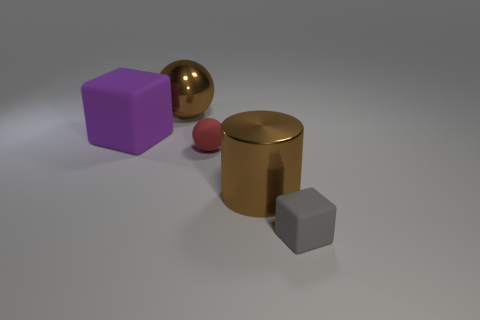How many other objects are there of the same material as the small block?
Make the answer very short. 2. There is a big metal object that is in front of the cube on the left side of the gray thing; how many large things are right of it?
Keep it short and to the point. 0. What number of shiny objects are either large blocks or objects?
Offer a terse response. 2. How big is the matte object left of the tiny object that is on the left side of the gray matte block?
Your answer should be compact. Large. Does the large object that is left of the shiny ball have the same color as the small thing that is to the left of the tiny cube?
Ensure brevity in your answer.  No. The object that is both on the left side of the cylinder and in front of the big matte block is what color?
Provide a short and direct response. Red. Is the material of the tiny red thing the same as the brown ball?
Make the answer very short. No. What number of small things are either brown rubber balls or purple cubes?
Your response must be concise. 0. Are there any other things that have the same shape as the gray rubber thing?
Provide a short and direct response. Yes. What color is the other cube that is the same material as the small gray block?
Offer a very short reply. Purple. 